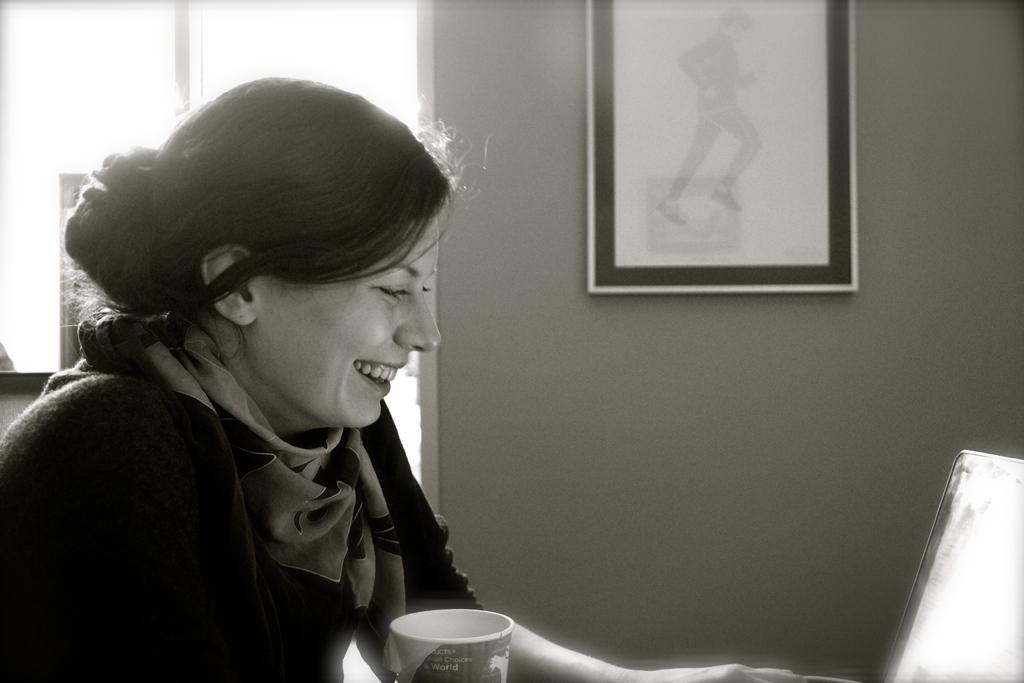Who is present in the image? There is a woman in the image. What is the woman's expression? The woman is smiling. What objects can be seen in the image? There is a cup, a laptop, and other items in the image. What is visible in the background of the image? There is a window and a frame attached to the wall in the background of the image. What subject is the woman teaching in the image? There is no indication in the image that the woman is teaching a subject. How many sons can be seen in the image? There are no sons present in the image. 